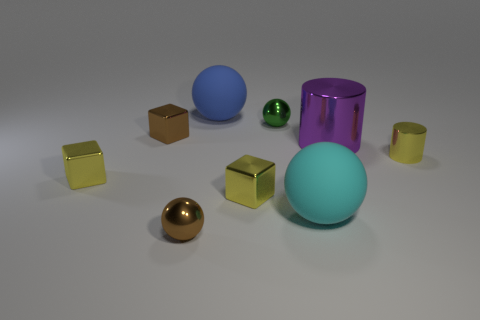Subtract all brown spheres. How many spheres are left? 3 Add 2 purple metallic cylinders. How many purple metallic cylinders exist? 3 Subtract all brown balls. How many balls are left? 3 Subtract 1 purple cylinders. How many objects are left? 8 Subtract all blocks. How many objects are left? 6 Subtract 1 cubes. How many cubes are left? 2 Subtract all cyan cylinders. Subtract all purple balls. How many cylinders are left? 2 Subtract all purple cylinders. How many yellow cubes are left? 2 Subtract all big red matte objects. Subtract all green objects. How many objects are left? 8 Add 8 purple metal cylinders. How many purple metal cylinders are left? 9 